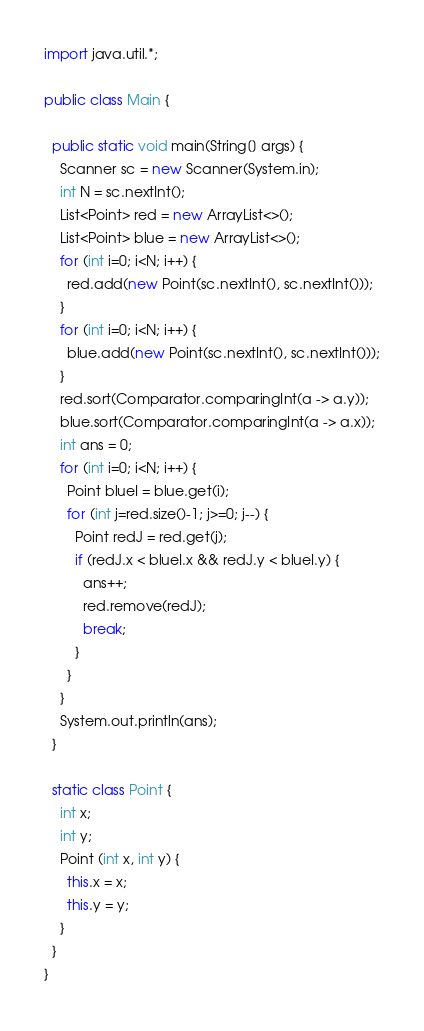Convert code to text. <code><loc_0><loc_0><loc_500><loc_500><_Java_>import java.util.*;

public class Main {

  public static void main(String[] args) {
    Scanner sc = new Scanner(System.in);
    int N = sc.nextInt();
    List<Point> red = new ArrayList<>();
    List<Point> blue = new ArrayList<>();
    for (int i=0; i<N; i++) {
      red.add(new Point(sc.nextInt(), sc.nextInt()));
    }
    for (int i=0; i<N; i++) {
      blue.add(new Point(sc.nextInt(), sc.nextInt()));
    }
    red.sort(Comparator.comparingInt(a -> a.y));
    blue.sort(Comparator.comparingInt(a -> a.x));
    int ans = 0;
    for (int i=0; i<N; i++) {
      Point blueI = blue.get(i);
      for (int j=red.size()-1; j>=0; j--) {
        Point redJ = red.get(j);
        if (redJ.x < blueI.x && redJ.y < blueI.y) {
          ans++;
          red.remove(redJ);
          break;
        }
      }
    }
    System.out.println(ans);
  }
  
  static class Point {
    int x;
    int y;
    Point (int x, int y) {
      this.x = x;
      this.y = y;
    }
  }
}
</code> 